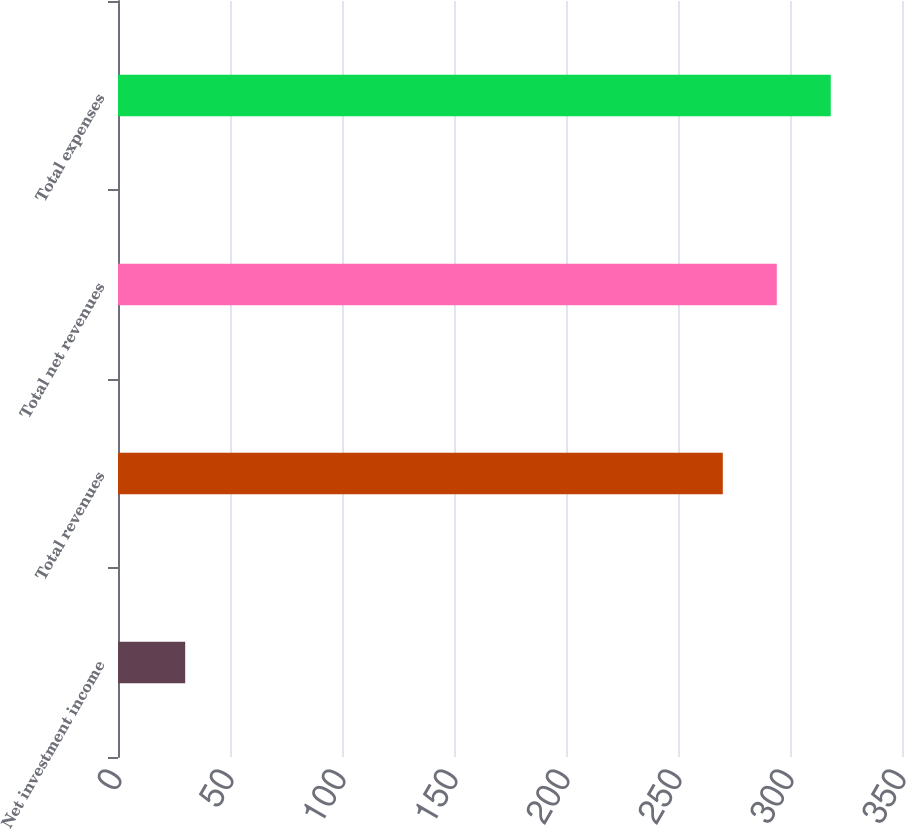<chart> <loc_0><loc_0><loc_500><loc_500><bar_chart><fcel>Net investment income<fcel>Total revenues<fcel>Total net revenues<fcel>Total expenses<nl><fcel>30<fcel>270<fcel>294.1<fcel>318.2<nl></chart> 